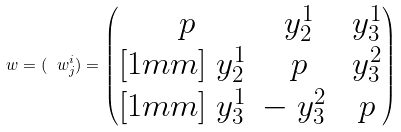Convert formula to latex. <formula><loc_0><loc_0><loc_500><loc_500>\ w = ( \ w ^ { i } _ { j } ) = \begin{pmatrix} \ p & \ y ^ { 1 } _ { 2 } & \ y ^ { 1 } _ { 3 } \\ [ 1 m m ] \ y ^ { 1 } _ { 2 } & \ p & \ y ^ { 2 } _ { 3 } \\ [ 1 m m ] \ y ^ { 1 } _ { 3 } & - \ y ^ { 2 } _ { 3 } & \ p \end{pmatrix}</formula> 